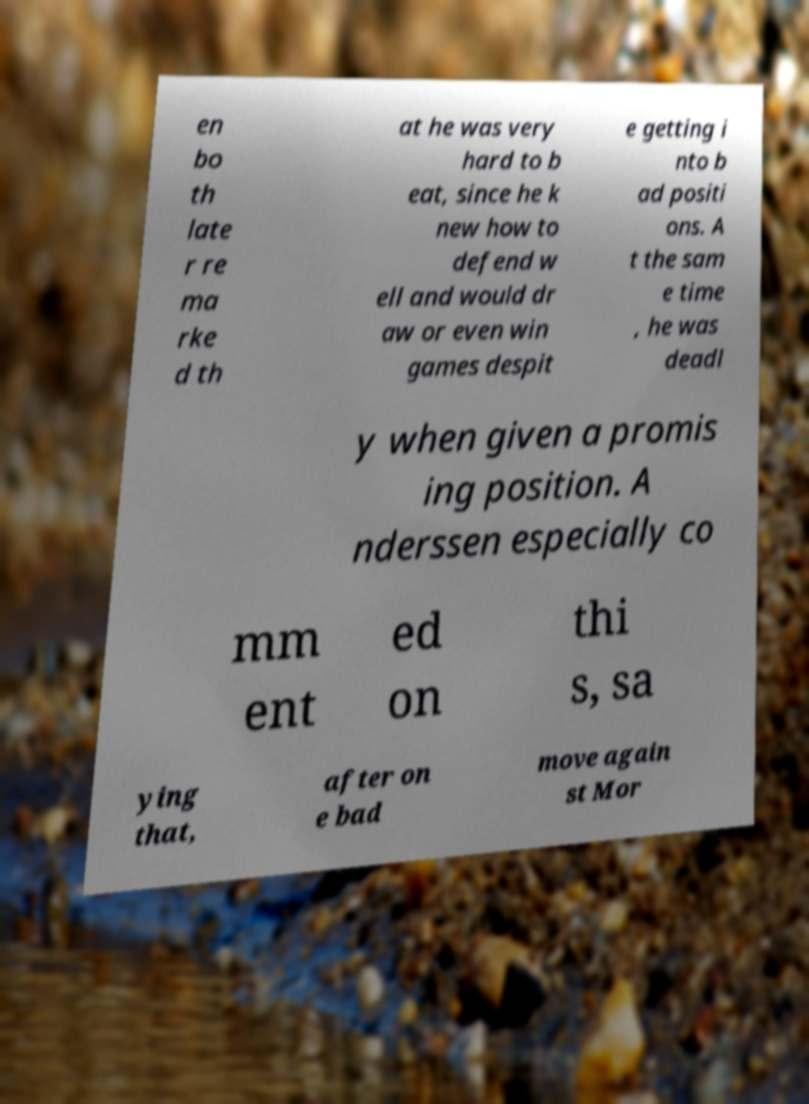Can you read and provide the text displayed in the image?This photo seems to have some interesting text. Can you extract and type it out for me? en bo th late r re ma rke d th at he was very hard to b eat, since he k new how to defend w ell and would dr aw or even win games despit e getting i nto b ad positi ons. A t the sam e time , he was deadl y when given a promis ing position. A nderssen especially co mm ent ed on thi s, sa ying that, after on e bad move again st Mor 